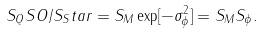Convert formula to latex. <formula><loc_0><loc_0><loc_500><loc_500>S _ { Q } S O / S _ { S } t a r = S _ { M } \exp [ - \sigma _ { \phi } ^ { 2 } ] = S _ { M } S _ { \phi } .</formula> 